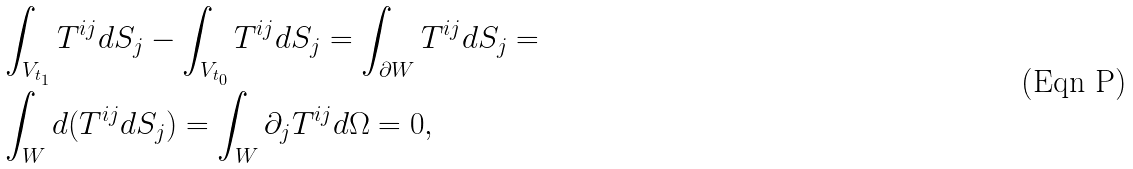<formula> <loc_0><loc_0><loc_500><loc_500>& \int _ { V _ { t _ { 1 } } } T ^ { i j } d S _ { j } - \int _ { V _ { t _ { 0 } } } T ^ { i j } d S _ { j } = \int _ { \partial W } T ^ { i j } d S _ { j } = \\ & \int _ { W } d ( T ^ { i j } d S _ { j } ) = \int _ { W } \partial _ { j } T ^ { i j } d \Omega = 0 ,</formula> 